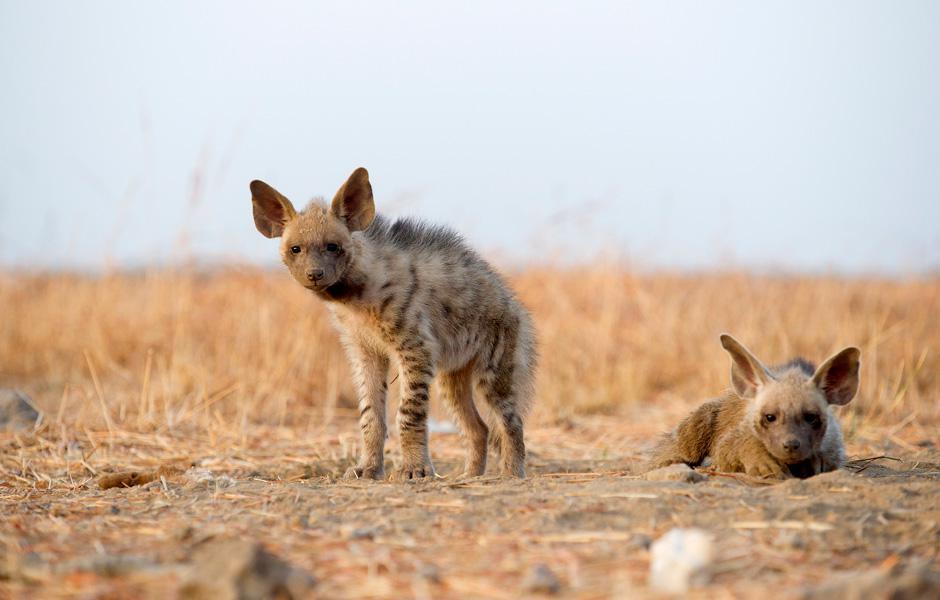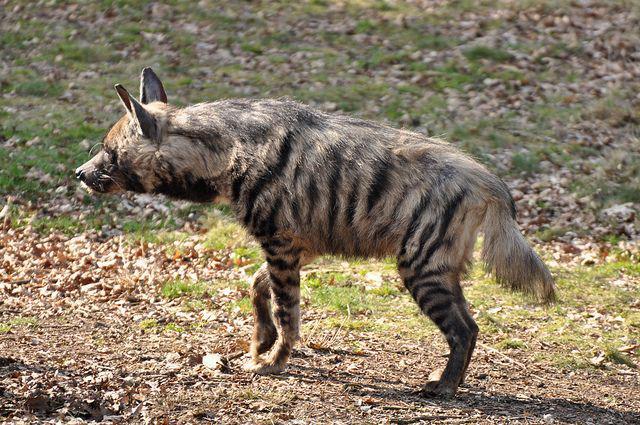The first image is the image on the left, the second image is the image on the right. For the images displayed, is the sentence "Some of the hyenas are laying down." factually correct? Answer yes or no. Yes. 